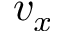<formula> <loc_0><loc_0><loc_500><loc_500>v _ { x }</formula> 